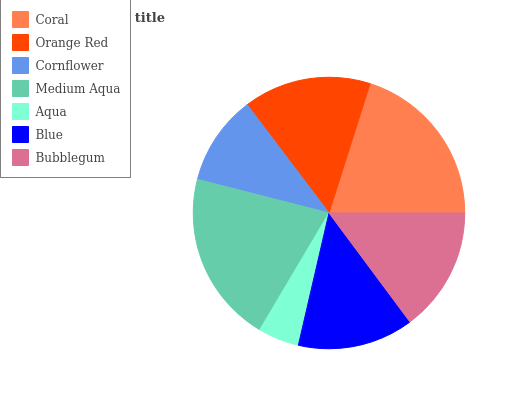Is Aqua the minimum?
Answer yes or no. Yes. Is Medium Aqua the maximum?
Answer yes or no. Yes. Is Orange Red the minimum?
Answer yes or no. No. Is Orange Red the maximum?
Answer yes or no. No. Is Coral greater than Orange Red?
Answer yes or no. Yes. Is Orange Red less than Coral?
Answer yes or no. Yes. Is Orange Red greater than Coral?
Answer yes or no. No. Is Coral less than Orange Red?
Answer yes or no. No. Is Bubblegum the high median?
Answer yes or no. Yes. Is Bubblegum the low median?
Answer yes or no. Yes. Is Medium Aqua the high median?
Answer yes or no. No. Is Medium Aqua the low median?
Answer yes or no. No. 